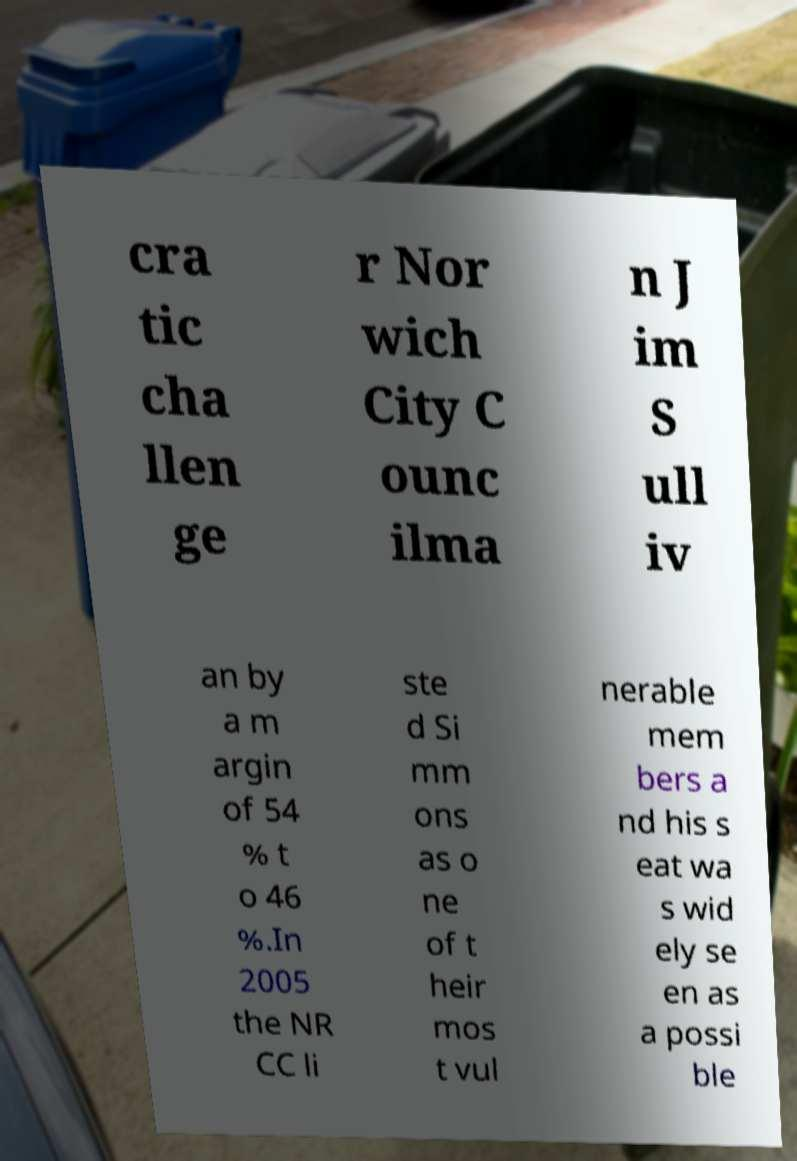Please identify and transcribe the text found in this image. cra tic cha llen ge r Nor wich City C ounc ilma n J im S ull iv an by a m argin of 54 % t o 46 %.In 2005 the NR CC li ste d Si mm ons as o ne of t heir mos t vul nerable mem bers a nd his s eat wa s wid ely se en as a possi ble 